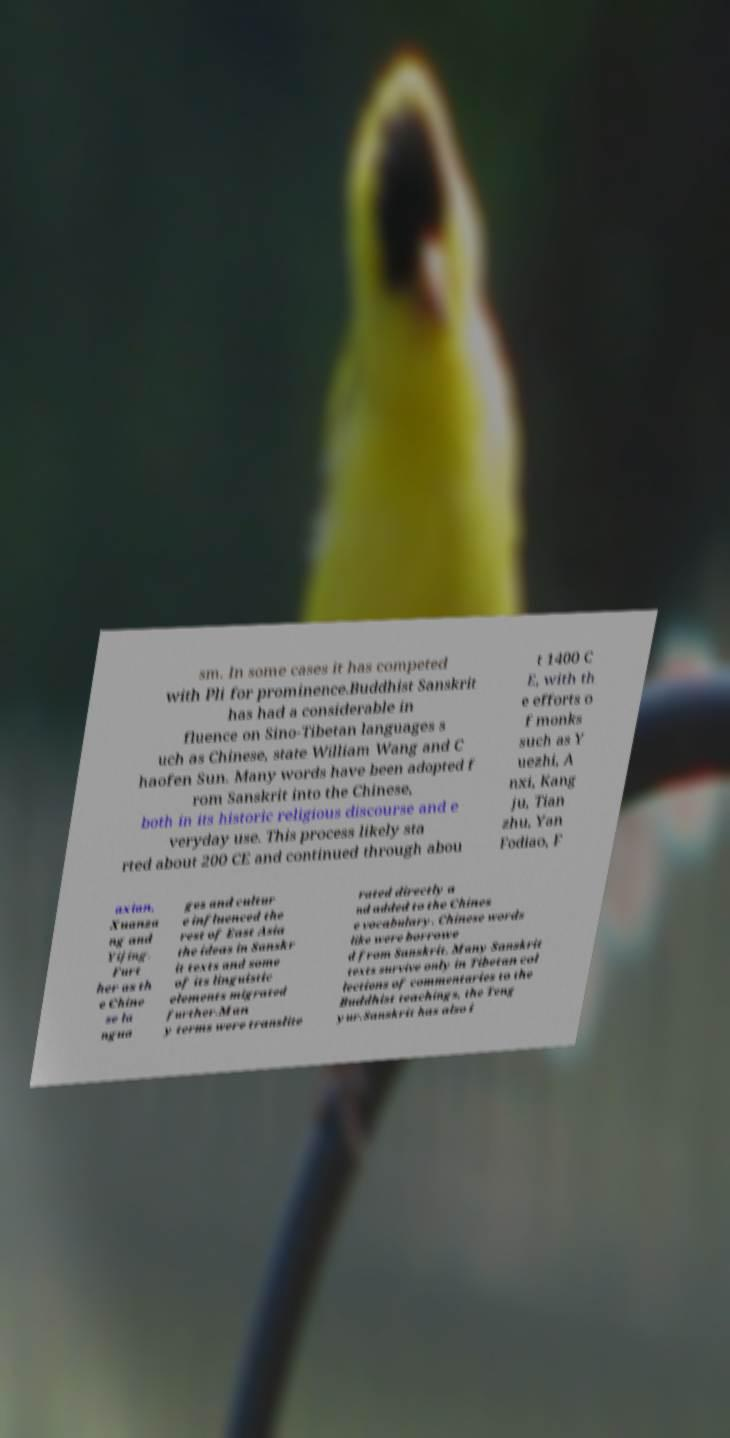What messages or text are displayed in this image? I need them in a readable, typed format. sm. In some cases it has competed with Pli for prominence.Buddhist Sanskrit has had a considerable in fluence on Sino-Tibetan languages s uch as Chinese, state William Wang and C haofen Sun. Many words have been adopted f rom Sanskrit into the Chinese, both in its historic religious discourse and e veryday use. This process likely sta rted about 200 CE and continued through abou t 1400 C E, with th e efforts o f monks such as Y uezhi, A nxi, Kang ju, Tian zhu, Yan Fodiao, F axian, Xuanza ng and Yijing. Furt her as th e Chine se la ngua ges and cultur e influenced the rest of East Asia the ideas in Sanskr it texts and some of its linguistic elements migrated further.Man y terms were translite rated directly a nd added to the Chines e vocabulary. Chinese words like were borrowe d from Sanskrit. Many Sanskrit texts survive only in Tibetan col lections of commentaries to the Buddhist teachings, the Teng yur.Sanskrit has also i 